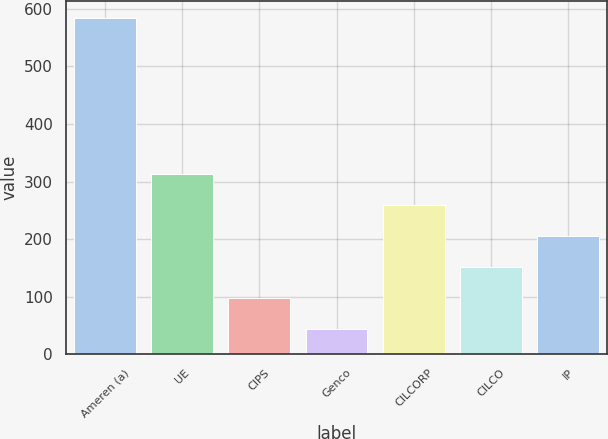Convert chart. <chart><loc_0><loc_0><loc_500><loc_500><bar_chart><fcel>Ameren (a)<fcel>UE<fcel>CIPS<fcel>Genco<fcel>CILCORP<fcel>CILCO<fcel>IP<nl><fcel>584<fcel>314<fcel>98<fcel>44<fcel>260<fcel>152<fcel>206<nl></chart> 